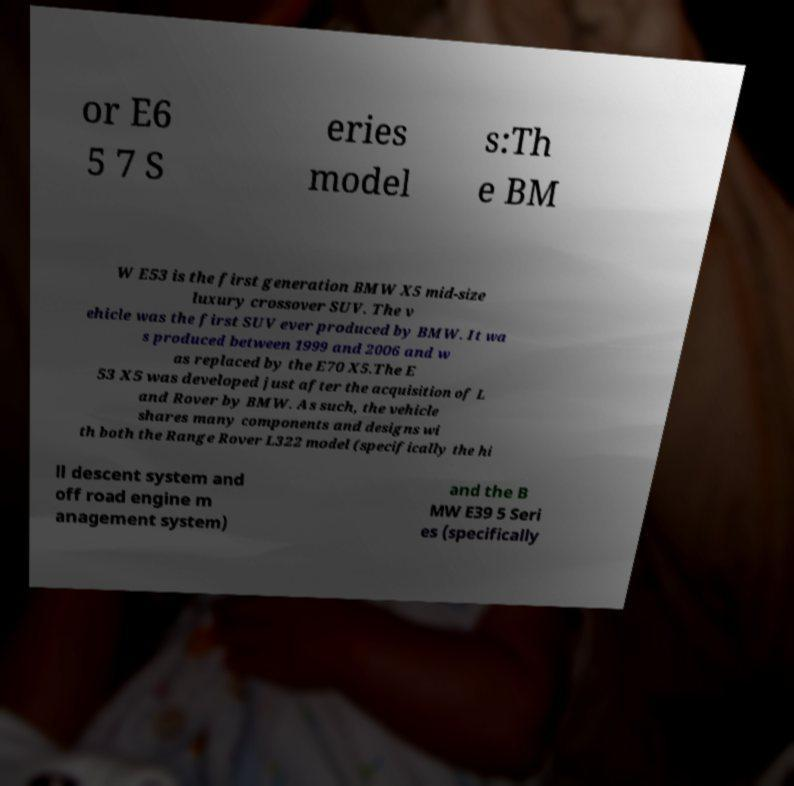There's text embedded in this image that I need extracted. Can you transcribe it verbatim? or E6 5 7 S eries model s:Th e BM W E53 is the first generation BMW X5 mid-size luxury crossover SUV. The v ehicle was the first SUV ever produced by BMW. It wa s produced between 1999 and 2006 and w as replaced by the E70 X5.The E 53 X5 was developed just after the acquisition of L and Rover by BMW. As such, the vehicle shares many components and designs wi th both the Range Rover L322 model (specifically the hi ll descent system and off road engine m anagement system) and the B MW E39 5 Seri es (specifically 